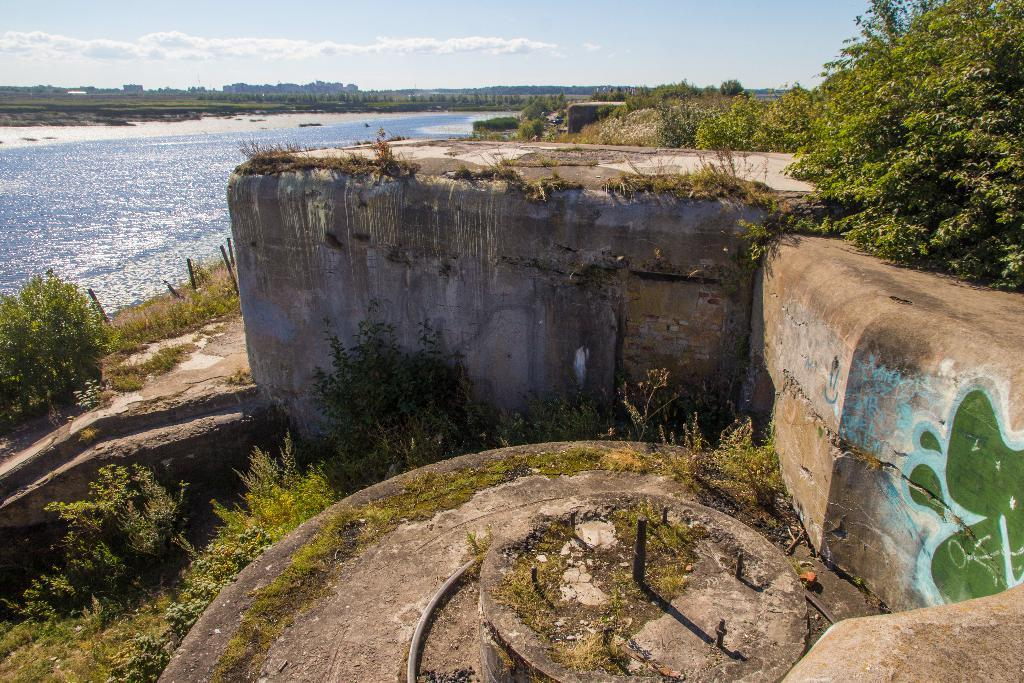Where was the image taken? The image was taken outside. What can be seen on the left side of the image? There are bushes and trees on the left side of the image. What can be seen on the right side of the image? There are bushes and trees on the right side of the image. What is present on the left side of the image besides the bushes and trees? There is water on the left side of the image. What is visible at the top of the image? The sky is visible at the top of the image. How many dogs are visible in the image? There are no dogs present in the image. What type of dust can be seen covering the trees in the image? There is no dust visible in the image; the trees appear to be clean. 